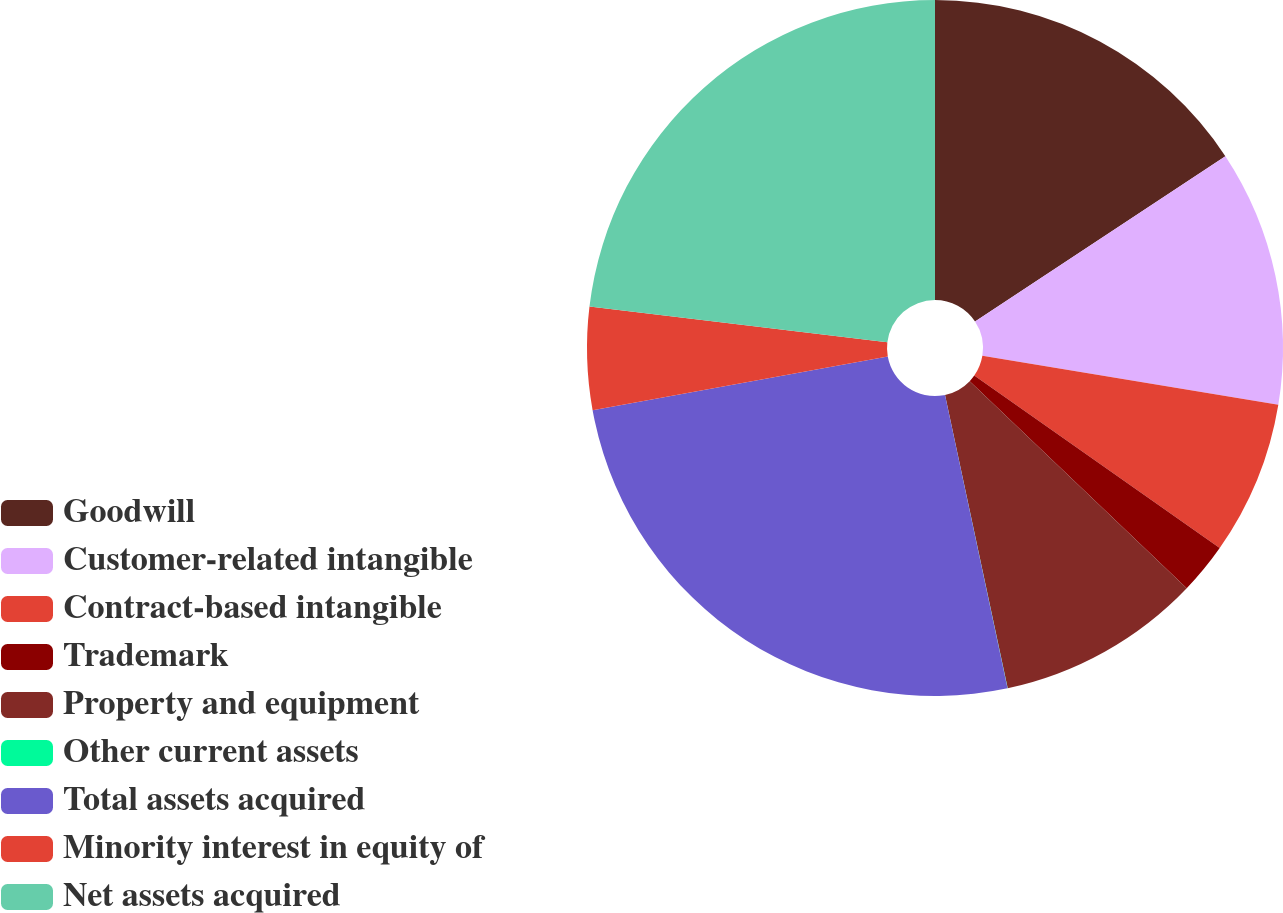Convert chart. <chart><loc_0><loc_0><loc_500><loc_500><pie_chart><fcel>Goodwill<fcel>Customer-related intangible<fcel>Contract-based intangible<fcel>Trademark<fcel>Property and equipment<fcel>Other current assets<fcel>Total assets acquired<fcel>Minority interest in equity of<fcel>Net assets acquired<nl><fcel>15.71%<fcel>11.9%<fcel>7.14%<fcel>2.38%<fcel>9.52%<fcel>0.01%<fcel>25.48%<fcel>4.76%<fcel>23.1%<nl></chart> 